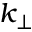<formula> <loc_0><loc_0><loc_500><loc_500>k _ { \perp }</formula> 